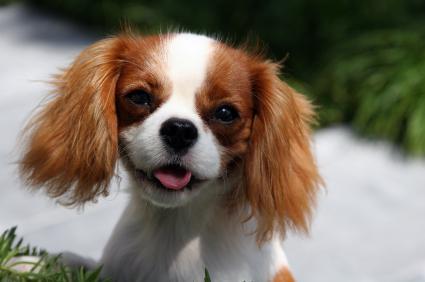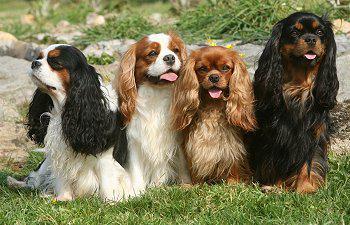The first image is the image on the left, the second image is the image on the right. For the images shown, is this caption "At least one animal is on the grass." true? Answer yes or no. Yes. 